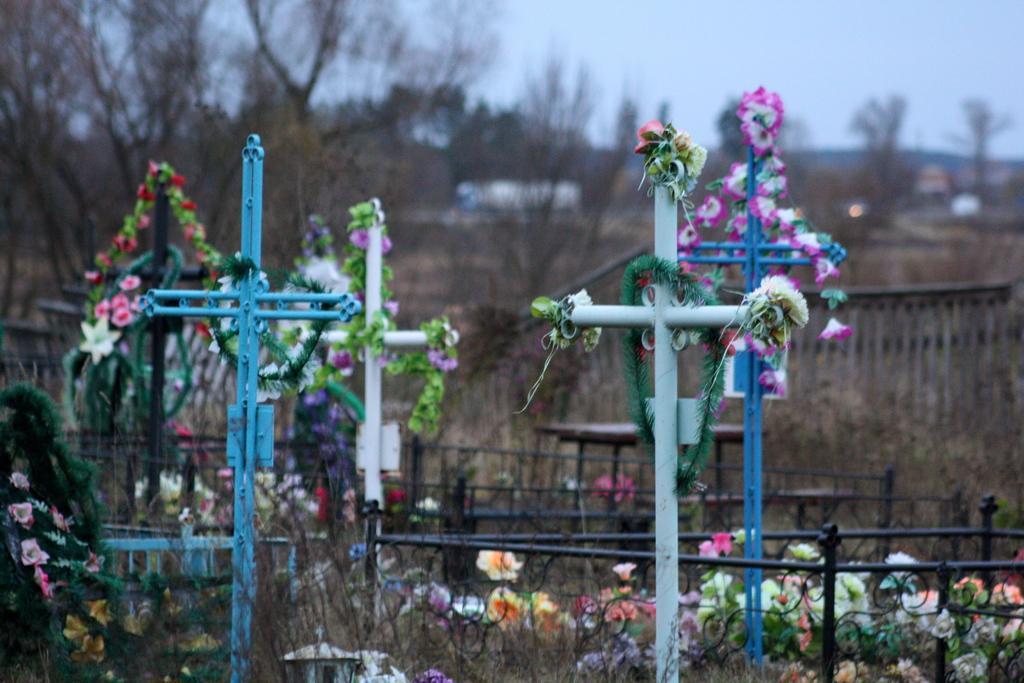Please provide a concise description of this image. In the foreground of this image, there are artificial decorations to the cross structures and also see artificial flowers, railing, and the plants and also tables in the background. We can also see a wooden structure, trees, mountain and the sky in the background. 